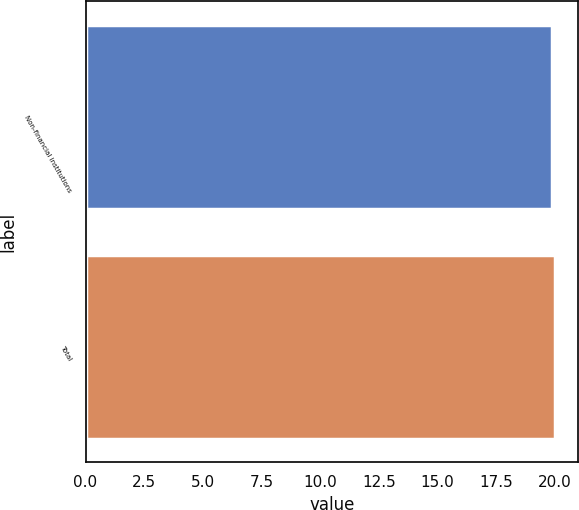<chart> <loc_0><loc_0><loc_500><loc_500><bar_chart><fcel>Non-financial institutions<fcel>Total<nl><fcel>19.9<fcel>20<nl></chart> 